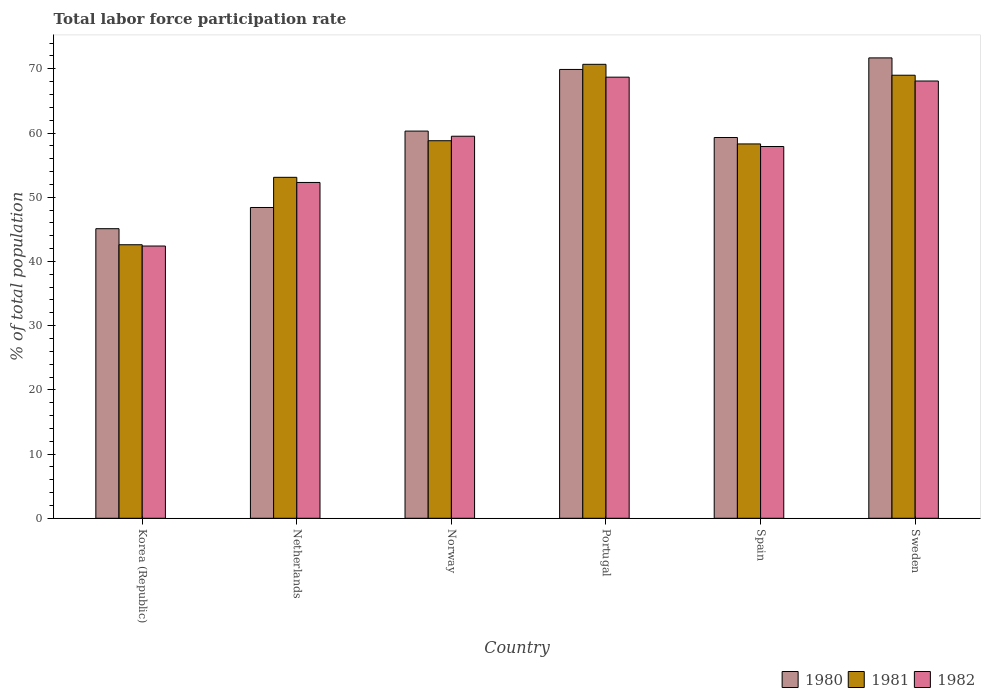How many different coloured bars are there?
Give a very brief answer. 3. How many groups of bars are there?
Provide a succinct answer. 6. Are the number of bars per tick equal to the number of legend labels?
Your answer should be compact. Yes. How many bars are there on the 1st tick from the left?
Ensure brevity in your answer.  3. How many bars are there on the 6th tick from the right?
Your response must be concise. 3. What is the total labor force participation rate in 1982 in Norway?
Provide a short and direct response. 59.5. Across all countries, what is the maximum total labor force participation rate in 1981?
Provide a short and direct response. 70.7. Across all countries, what is the minimum total labor force participation rate in 1981?
Make the answer very short. 42.6. In which country was the total labor force participation rate in 1981 maximum?
Your answer should be compact. Portugal. What is the total total labor force participation rate in 1981 in the graph?
Offer a terse response. 352.5. What is the difference between the total labor force participation rate in 1981 in Korea (Republic) and the total labor force participation rate in 1980 in Norway?
Offer a very short reply. -17.7. What is the average total labor force participation rate in 1981 per country?
Provide a short and direct response. 58.75. What is the difference between the total labor force participation rate of/in 1982 and total labor force participation rate of/in 1980 in Sweden?
Offer a very short reply. -3.6. What is the ratio of the total labor force participation rate in 1981 in Netherlands to that in Sweden?
Your answer should be very brief. 0.77. Is the total labor force participation rate in 1982 in Portugal less than that in Sweden?
Provide a short and direct response. No. What is the difference between the highest and the second highest total labor force participation rate in 1981?
Your response must be concise. -10.2. What is the difference between the highest and the lowest total labor force participation rate in 1981?
Keep it short and to the point. 28.1. In how many countries, is the total labor force participation rate in 1981 greater than the average total labor force participation rate in 1981 taken over all countries?
Provide a succinct answer. 3. What does the 1st bar from the left in Korea (Republic) represents?
Give a very brief answer. 1980. Is it the case that in every country, the sum of the total labor force participation rate in 1981 and total labor force participation rate in 1980 is greater than the total labor force participation rate in 1982?
Provide a short and direct response. Yes. Are all the bars in the graph horizontal?
Your answer should be compact. No. How many countries are there in the graph?
Ensure brevity in your answer.  6. What is the difference between two consecutive major ticks on the Y-axis?
Your response must be concise. 10. Are the values on the major ticks of Y-axis written in scientific E-notation?
Offer a very short reply. No. Where does the legend appear in the graph?
Ensure brevity in your answer.  Bottom right. What is the title of the graph?
Keep it short and to the point. Total labor force participation rate. Does "1995" appear as one of the legend labels in the graph?
Provide a succinct answer. No. What is the label or title of the Y-axis?
Make the answer very short. % of total population. What is the % of total population of 1980 in Korea (Republic)?
Offer a very short reply. 45.1. What is the % of total population of 1981 in Korea (Republic)?
Your answer should be compact. 42.6. What is the % of total population in 1982 in Korea (Republic)?
Provide a succinct answer. 42.4. What is the % of total population of 1980 in Netherlands?
Ensure brevity in your answer.  48.4. What is the % of total population of 1981 in Netherlands?
Ensure brevity in your answer.  53.1. What is the % of total population in 1982 in Netherlands?
Keep it short and to the point. 52.3. What is the % of total population in 1980 in Norway?
Give a very brief answer. 60.3. What is the % of total population in 1981 in Norway?
Provide a succinct answer. 58.8. What is the % of total population of 1982 in Norway?
Your response must be concise. 59.5. What is the % of total population of 1980 in Portugal?
Your answer should be very brief. 69.9. What is the % of total population in 1981 in Portugal?
Your response must be concise. 70.7. What is the % of total population in 1982 in Portugal?
Give a very brief answer. 68.7. What is the % of total population of 1980 in Spain?
Keep it short and to the point. 59.3. What is the % of total population in 1981 in Spain?
Give a very brief answer. 58.3. What is the % of total population in 1982 in Spain?
Your response must be concise. 57.9. What is the % of total population of 1980 in Sweden?
Offer a terse response. 71.7. What is the % of total population of 1982 in Sweden?
Keep it short and to the point. 68.1. Across all countries, what is the maximum % of total population of 1980?
Ensure brevity in your answer.  71.7. Across all countries, what is the maximum % of total population in 1981?
Your answer should be very brief. 70.7. Across all countries, what is the maximum % of total population of 1982?
Provide a short and direct response. 68.7. Across all countries, what is the minimum % of total population of 1980?
Your response must be concise. 45.1. Across all countries, what is the minimum % of total population of 1981?
Offer a terse response. 42.6. Across all countries, what is the minimum % of total population of 1982?
Offer a terse response. 42.4. What is the total % of total population in 1980 in the graph?
Your answer should be very brief. 354.7. What is the total % of total population in 1981 in the graph?
Your response must be concise. 352.5. What is the total % of total population in 1982 in the graph?
Provide a short and direct response. 348.9. What is the difference between the % of total population in 1980 in Korea (Republic) and that in Netherlands?
Offer a terse response. -3.3. What is the difference between the % of total population in 1981 in Korea (Republic) and that in Netherlands?
Offer a terse response. -10.5. What is the difference between the % of total population in 1982 in Korea (Republic) and that in Netherlands?
Your response must be concise. -9.9. What is the difference between the % of total population in 1980 in Korea (Republic) and that in Norway?
Make the answer very short. -15.2. What is the difference between the % of total population in 1981 in Korea (Republic) and that in Norway?
Offer a terse response. -16.2. What is the difference between the % of total population in 1982 in Korea (Republic) and that in Norway?
Keep it short and to the point. -17.1. What is the difference between the % of total population in 1980 in Korea (Republic) and that in Portugal?
Make the answer very short. -24.8. What is the difference between the % of total population of 1981 in Korea (Republic) and that in Portugal?
Your response must be concise. -28.1. What is the difference between the % of total population in 1982 in Korea (Republic) and that in Portugal?
Ensure brevity in your answer.  -26.3. What is the difference between the % of total population of 1980 in Korea (Republic) and that in Spain?
Offer a very short reply. -14.2. What is the difference between the % of total population in 1981 in Korea (Republic) and that in Spain?
Your answer should be compact. -15.7. What is the difference between the % of total population in 1982 in Korea (Republic) and that in Spain?
Keep it short and to the point. -15.5. What is the difference between the % of total population of 1980 in Korea (Republic) and that in Sweden?
Your answer should be compact. -26.6. What is the difference between the % of total population of 1981 in Korea (Republic) and that in Sweden?
Your answer should be very brief. -26.4. What is the difference between the % of total population in 1982 in Korea (Republic) and that in Sweden?
Ensure brevity in your answer.  -25.7. What is the difference between the % of total population of 1980 in Netherlands and that in Portugal?
Keep it short and to the point. -21.5. What is the difference between the % of total population in 1981 in Netherlands and that in Portugal?
Offer a terse response. -17.6. What is the difference between the % of total population of 1982 in Netherlands and that in Portugal?
Keep it short and to the point. -16.4. What is the difference between the % of total population in 1981 in Netherlands and that in Spain?
Keep it short and to the point. -5.2. What is the difference between the % of total population of 1980 in Netherlands and that in Sweden?
Offer a very short reply. -23.3. What is the difference between the % of total population of 1981 in Netherlands and that in Sweden?
Your answer should be compact. -15.9. What is the difference between the % of total population of 1982 in Netherlands and that in Sweden?
Your answer should be very brief. -15.8. What is the difference between the % of total population of 1980 in Norway and that in Portugal?
Your answer should be very brief. -9.6. What is the difference between the % of total population of 1980 in Norway and that in Spain?
Keep it short and to the point. 1. What is the difference between the % of total population of 1981 in Norway and that in Spain?
Provide a short and direct response. 0.5. What is the difference between the % of total population in 1982 in Norway and that in Spain?
Make the answer very short. 1.6. What is the difference between the % of total population in 1981 in Norway and that in Sweden?
Offer a very short reply. -10.2. What is the difference between the % of total population in 1981 in Portugal and that in Spain?
Give a very brief answer. 12.4. What is the difference between the % of total population of 1980 in Portugal and that in Sweden?
Your response must be concise. -1.8. What is the difference between the % of total population of 1981 in Portugal and that in Sweden?
Ensure brevity in your answer.  1.7. What is the difference between the % of total population of 1980 in Spain and that in Sweden?
Give a very brief answer. -12.4. What is the difference between the % of total population in 1981 in Spain and that in Sweden?
Give a very brief answer. -10.7. What is the difference between the % of total population of 1982 in Spain and that in Sweden?
Make the answer very short. -10.2. What is the difference between the % of total population in 1981 in Korea (Republic) and the % of total population in 1982 in Netherlands?
Your response must be concise. -9.7. What is the difference between the % of total population of 1980 in Korea (Republic) and the % of total population of 1981 in Norway?
Make the answer very short. -13.7. What is the difference between the % of total population of 1980 in Korea (Republic) and the % of total population of 1982 in Norway?
Your response must be concise. -14.4. What is the difference between the % of total population of 1981 in Korea (Republic) and the % of total population of 1982 in Norway?
Keep it short and to the point. -16.9. What is the difference between the % of total population in 1980 in Korea (Republic) and the % of total population in 1981 in Portugal?
Keep it short and to the point. -25.6. What is the difference between the % of total population of 1980 in Korea (Republic) and the % of total population of 1982 in Portugal?
Give a very brief answer. -23.6. What is the difference between the % of total population in 1981 in Korea (Republic) and the % of total population in 1982 in Portugal?
Keep it short and to the point. -26.1. What is the difference between the % of total population of 1980 in Korea (Republic) and the % of total population of 1982 in Spain?
Ensure brevity in your answer.  -12.8. What is the difference between the % of total population of 1981 in Korea (Republic) and the % of total population of 1982 in Spain?
Your answer should be very brief. -15.3. What is the difference between the % of total population in 1980 in Korea (Republic) and the % of total population in 1981 in Sweden?
Your answer should be compact. -23.9. What is the difference between the % of total population in 1980 in Korea (Republic) and the % of total population in 1982 in Sweden?
Offer a very short reply. -23. What is the difference between the % of total population of 1981 in Korea (Republic) and the % of total population of 1982 in Sweden?
Make the answer very short. -25.5. What is the difference between the % of total population in 1981 in Netherlands and the % of total population in 1982 in Norway?
Give a very brief answer. -6.4. What is the difference between the % of total population in 1980 in Netherlands and the % of total population in 1981 in Portugal?
Your response must be concise. -22.3. What is the difference between the % of total population of 1980 in Netherlands and the % of total population of 1982 in Portugal?
Your answer should be compact. -20.3. What is the difference between the % of total population in 1981 in Netherlands and the % of total population in 1982 in Portugal?
Offer a terse response. -15.6. What is the difference between the % of total population of 1980 in Netherlands and the % of total population of 1981 in Sweden?
Offer a very short reply. -20.6. What is the difference between the % of total population of 1980 in Netherlands and the % of total population of 1982 in Sweden?
Your response must be concise. -19.7. What is the difference between the % of total population of 1980 in Norway and the % of total population of 1981 in Portugal?
Give a very brief answer. -10.4. What is the difference between the % of total population in 1980 in Norway and the % of total population in 1981 in Spain?
Offer a very short reply. 2. What is the difference between the % of total population in 1981 in Norway and the % of total population in 1982 in Spain?
Ensure brevity in your answer.  0.9. What is the difference between the % of total population of 1981 in Norway and the % of total population of 1982 in Sweden?
Your answer should be compact. -9.3. What is the difference between the % of total population in 1980 in Portugal and the % of total population in 1982 in Spain?
Provide a succinct answer. 12. What is the difference between the % of total population in 1980 in Portugal and the % of total population in 1981 in Sweden?
Your response must be concise. 0.9. What is the difference between the % of total population in 1980 in Portugal and the % of total population in 1982 in Sweden?
Keep it short and to the point. 1.8. What is the difference between the % of total population in 1980 in Spain and the % of total population in 1982 in Sweden?
Your answer should be very brief. -8.8. What is the difference between the % of total population in 1981 in Spain and the % of total population in 1982 in Sweden?
Offer a very short reply. -9.8. What is the average % of total population of 1980 per country?
Provide a short and direct response. 59.12. What is the average % of total population in 1981 per country?
Make the answer very short. 58.75. What is the average % of total population of 1982 per country?
Keep it short and to the point. 58.15. What is the difference between the % of total population of 1980 and % of total population of 1981 in Korea (Republic)?
Ensure brevity in your answer.  2.5. What is the difference between the % of total population in 1980 and % of total population in 1981 in Netherlands?
Your answer should be very brief. -4.7. What is the difference between the % of total population of 1980 and % of total population of 1982 in Netherlands?
Your answer should be very brief. -3.9. What is the difference between the % of total population in 1980 and % of total population in 1982 in Portugal?
Provide a short and direct response. 1.2. What is the difference between the % of total population in 1981 and % of total population in 1982 in Portugal?
Your response must be concise. 2. What is the difference between the % of total population in 1980 and % of total population in 1981 in Spain?
Your response must be concise. 1. What is the difference between the % of total population of 1980 and % of total population of 1982 in Spain?
Offer a very short reply. 1.4. What is the difference between the % of total population in 1981 and % of total population in 1982 in Spain?
Provide a short and direct response. 0.4. What is the difference between the % of total population in 1980 and % of total population in 1981 in Sweden?
Make the answer very short. 2.7. What is the ratio of the % of total population of 1980 in Korea (Republic) to that in Netherlands?
Offer a terse response. 0.93. What is the ratio of the % of total population in 1981 in Korea (Republic) to that in Netherlands?
Keep it short and to the point. 0.8. What is the ratio of the % of total population of 1982 in Korea (Republic) to that in Netherlands?
Provide a short and direct response. 0.81. What is the ratio of the % of total population of 1980 in Korea (Republic) to that in Norway?
Your answer should be compact. 0.75. What is the ratio of the % of total population of 1981 in Korea (Republic) to that in Norway?
Your answer should be compact. 0.72. What is the ratio of the % of total population in 1982 in Korea (Republic) to that in Norway?
Ensure brevity in your answer.  0.71. What is the ratio of the % of total population in 1980 in Korea (Republic) to that in Portugal?
Give a very brief answer. 0.65. What is the ratio of the % of total population in 1981 in Korea (Republic) to that in Portugal?
Keep it short and to the point. 0.6. What is the ratio of the % of total population in 1982 in Korea (Republic) to that in Portugal?
Offer a very short reply. 0.62. What is the ratio of the % of total population in 1980 in Korea (Republic) to that in Spain?
Your answer should be very brief. 0.76. What is the ratio of the % of total population in 1981 in Korea (Republic) to that in Spain?
Ensure brevity in your answer.  0.73. What is the ratio of the % of total population in 1982 in Korea (Republic) to that in Spain?
Make the answer very short. 0.73. What is the ratio of the % of total population in 1980 in Korea (Republic) to that in Sweden?
Keep it short and to the point. 0.63. What is the ratio of the % of total population in 1981 in Korea (Republic) to that in Sweden?
Your answer should be very brief. 0.62. What is the ratio of the % of total population of 1982 in Korea (Republic) to that in Sweden?
Offer a terse response. 0.62. What is the ratio of the % of total population of 1980 in Netherlands to that in Norway?
Your response must be concise. 0.8. What is the ratio of the % of total population in 1981 in Netherlands to that in Norway?
Keep it short and to the point. 0.9. What is the ratio of the % of total population in 1982 in Netherlands to that in Norway?
Your answer should be compact. 0.88. What is the ratio of the % of total population of 1980 in Netherlands to that in Portugal?
Give a very brief answer. 0.69. What is the ratio of the % of total population in 1981 in Netherlands to that in Portugal?
Your response must be concise. 0.75. What is the ratio of the % of total population of 1982 in Netherlands to that in Portugal?
Your response must be concise. 0.76. What is the ratio of the % of total population of 1980 in Netherlands to that in Spain?
Your answer should be very brief. 0.82. What is the ratio of the % of total population in 1981 in Netherlands to that in Spain?
Ensure brevity in your answer.  0.91. What is the ratio of the % of total population of 1982 in Netherlands to that in Spain?
Make the answer very short. 0.9. What is the ratio of the % of total population of 1980 in Netherlands to that in Sweden?
Provide a succinct answer. 0.68. What is the ratio of the % of total population in 1981 in Netherlands to that in Sweden?
Keep it short and to the point. 0.77. What is the ratio of the % of total population in 1982 in Netherlands to that in Sweden?
Your answer should be compact. 0.77. What is the ratio of the % of total population of 1980 in Norway to that in Portugal?
Ensure brevity in your answer.  0.86. What is the ratio of the % of total population in 1981 in Norway to that in Portugal?
Provide a succinct answer. 0.83. What is the ratio of the % of total population in 1982 in Norway to that in Portugal?
Make the answer very short. 0.87. What is the ratio of the % of total population of 1980 in Norway to that in Spain?
Provide a succinct answer. 1.02. What is the ratio of the % of total population of 1981 in Norway to that in Spain?
Offer a terse response. 1.01. What is the ratio of the % of total population in 1982 in Norway to that in Spain?
Provide a succinct answer. 1.03. What is the ratio of the % of total population of 1980 in Norway to that in Sweden?
Offer a terse response. 0.84. What is the ratio of the % of total population in 1981 in Norway to that in Sweden?
Give a very brief answer. 0.85. What is the ratio of the % of total population in 1982 in Norway to that in Sweden?
Provide a short and direct response. 0.87. What is the ratio of the % of total population of 1980 in Portugal to that in Spain?
Provide a short and direct response. 1.18. What is the ratio of the % of total population of 1981 in Portugal to that in Spain?
Your response must be concise. 1.21. What is the ratio of the % of total population of 1982 in Portugal to that in Spain?
Ensure brevity in your answer.  1.19. What is the ratio of the % of total population of 1980 in Portugal to that in Sweden?
Give a very brief answer. 0.97. What is the ratio of the % of total population in 1981 in Portugal to that in Sweden?
Your answer should be very brief. 1.02. What is the ratio of the % of total population of 1982 in Portugal to that in Sweden?
Provide a succinct answer. 1.01. What is the ratio of the % of total population in 1980 in Spain to that in Sweden?
Your answer should be compact. 0.83. What is the ratio of the % of total population of 1981 in Spain to that in Sweden?
Offer a terse response. 0.84. What is the ratio of the % of total population in 1982 in Spain to that in Sweden?
Provide a short and direct response. 0.85. What is the difference between the highest and the second highest % of total population of 1980?
Ensure brevity in your answer.  1.8. What is the difference between the highest and the second highest % of total population of 1981?
Ensure brevity in your answer.  1.7. What is the difference between the highest and the second highest % of total population in 1982?
Your answer should be compact. 0.6. What is the difference between the highest and the lowest % of total population in 1980?
Provide a succinct answer. 26.6. What is the difference between the highest and the lowest % of total population in 1981?
Provide a short and direct response. 28.1. What is the difference between the highest and the lowest % of total population in 1982?
Your answer should be very brief. 26.3. 